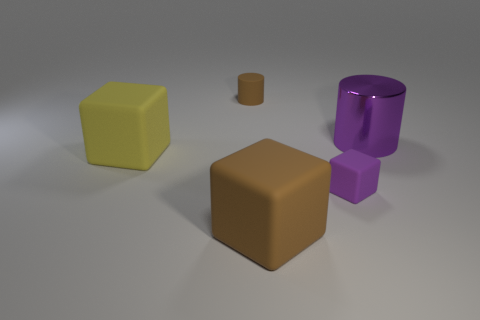Is there any other thing that is made of the same material as the large cylinder?
Keep it short and to the point. No. Is the large cylinder the same color as the small cube?
Keep it short and to the point. Yes. What material is the purple thing that is the same size as the brown cube?
Keep it short and to the point. Metal. Are there fewer purple things that are behind the big cylinder than big matte blocks?
Your answer should be very brief. Yes. What is the shape of the rubber object that is behind the big object to the left of the brown object in front of the tiny purple matte block?
Your answer should be compact. Cylinder. How big is the brown rubber thing that is right of the tiny matte cylinder?
Keep it short and to the point. Large. The brown thing that is the same size as the purple rubber thing is what shape?
Make the answer very short. Cylinder. How many objects are large red matte blocks or matte things that are on the right side of the tiny matte cylinder?
Your answer should be compact. 2. What number of yellow matte cubes are behind the cube right of the large matte cube that is in front of the large yellow object?
Your response must be concise. 1. What is the color of the other tiny cube that is made of the same material as the yellow block?
Your answer should be very brief. Purple. 